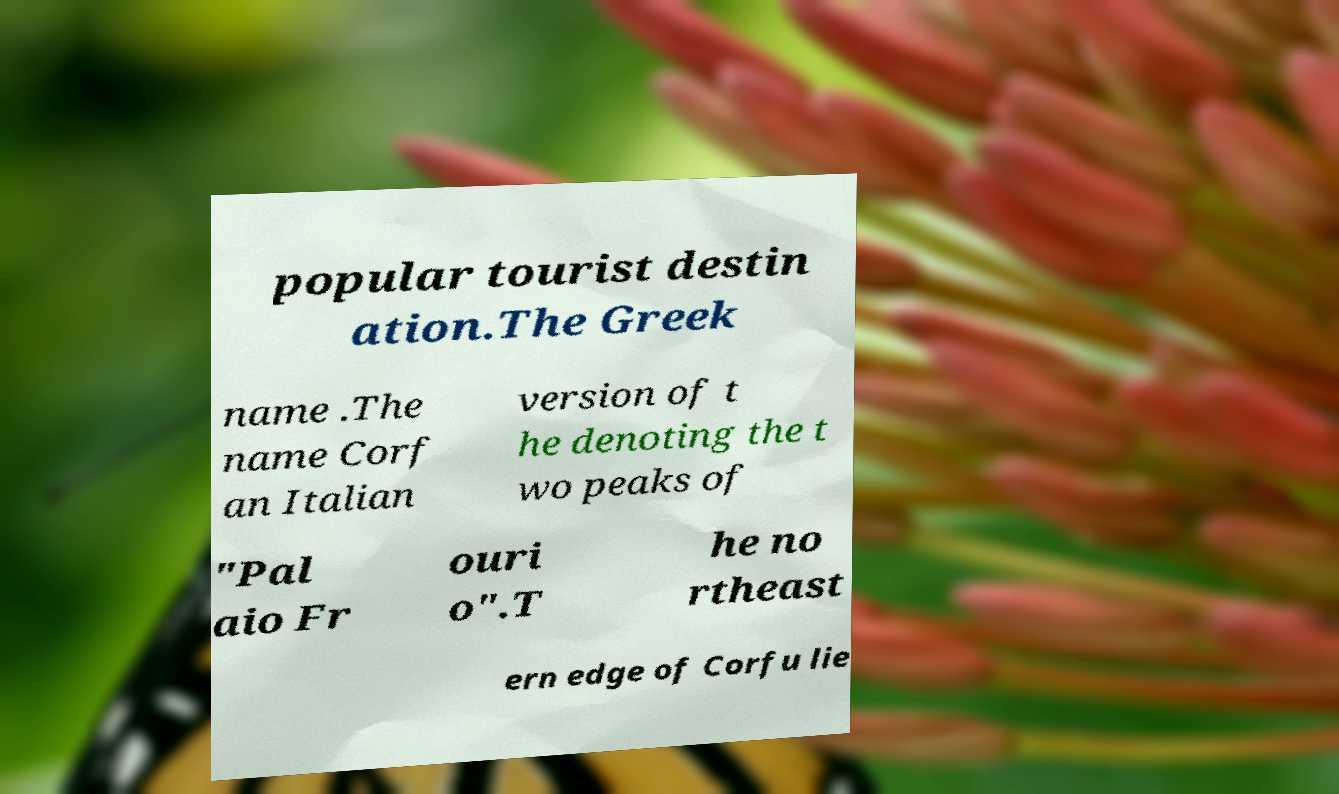I need the written content from this picture converted into text. Can you do that? popular tourist destin ation.The Greek name .The name Corf an Italian version of t he denoting the t wo peaks of "Pal aio Fr ouri o".T he no rtheast ern edge of Corfu lie 